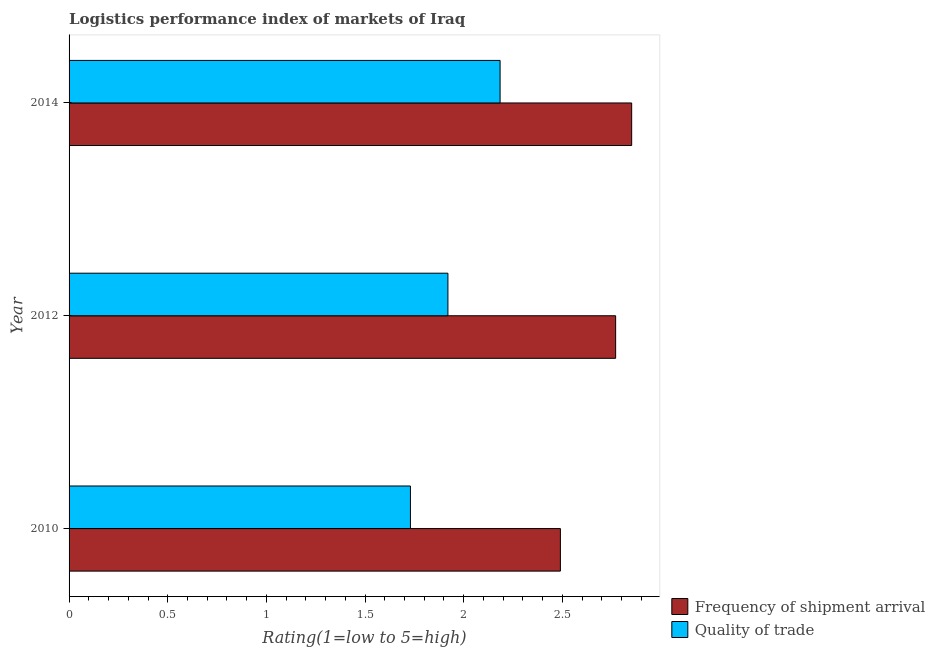How many groups of bars are there?
Offer a terse response. 3. How many bars are there on the 2nd tick from the bottom?
Offer a terse response. 2. In how many cases, is the number of bars for a given year not equal to the number of legend labels?
Provide a succinct answer. 0. What is the lpi of frequency of shipment arrival in 2012?
Give a very brief answer. 2.77. Across all years, what is the maximum lpi of frequency of shipment arrival?
Your answer should be very brief. 2.85. Across all years, what is the minimum lpi quality of trade?
Give a very brief answer. 1.73. In which year was the lpi quality of trade maximum?
Give a very brief answer. 2014. In which year was the lpi of frequency of shipment arrival minimum?
Make the answer very short. 2010. What is the total lpi quality of trade in the graph?
Provide a short and direct response. 5.83. What is the difference between the lpi quality of trade in 2012 and that in 2014?
Offer a very short reply. -0.26. What is the difference between the lpi quality of trade in 2010 and the lpi of frequency of shipment arrival in 2012?
Your response must be concise. -1.04. What is the average lpi quality of trade per year?
Give a very brief answer. 1.95. In the year 2012, what is the difference between the lpi quality of trade and lpi of frequency of shipment arrival?
Your answer should be very brief. -0.85. What is the ratio of the lpi quality of trade in 2010 to that in 2012?
Provide a short and direct response. 0.9. Is the lpi quality of trade in 2012 less than that in 2014?
Give a very brief answer. Yes. What is the difference between the highest and the second highest lpi quality of trade?
Your answer should be compact. 0.26. What is the difference between the highest and the lowest lpi of frequency of shipment arrival?
Offer a terse response. 0.36. In how many years, is the lpi of frequency of shipment arrival greater than the average lpi of frequency of shipment arrival taken over all years?
Keep it short and to the point. 2. Is the sum of the lpi of frequency of shipment arrival in 2012 and 2014 greater than the maximum lpi quality of trade across all years?
Offer a terse response. Yes. What does the 1st bar from the top in 2010 represents?
Provide a short and direct response. Quality of trade. What does the 2nd bar from the bottom in 2010 represents?
Your answer should be very brief. Quality of trade. Are the values on the major ticks of X-axis written in scientific E-notation?
Give a very brief answer. No. Does the graph contain any zero values?
Make the answer very short. No. Does the graph contain grids?
Keep it short and to the point. No. Where does the legend appear in the graph?
Provide a short and direct response. Bottom right. What is the title of the graph?
Keep it short and to the point. Logistics performance index of markets of Iraq. What is the label or title of the X-axis?
Your response must be concise. Rating(1=low to 5=high). What is the label or title of the Y-axis?
Provide a short and direct response. Year. What is the Rating(1=low to 5=high) of Frequency of shipment arrival in 2010?
Keep it short and to the point. 2.49. What is the Rating(1=low to 5=high) in Quality of trade in 2010?
Provide a short and direct response. 1.73. What is the Rating(1=low to 5=high) in Frequency of shipment arrival in 2012?
Offer a terse response. 2.77. What is the Rating(1=low to 5=high) in Quality of trade in 2012?
Your response must be concise. 1.92. What is the Rating(1=low to 5=high) in Frequency of shipment arrival in 2014?
Your response must be concise. 2.85. What is the Rating(1=low to 5=high) in Quality of trade in 2014?
Offer a very short reply. 2.18. Across all years, what is the maximum Rating(1=low to 5=high) in Frequency of shipment arrival?
Provide a succinct answer. 2.85. Across all years, what is the maximum Rating(1=low to 5=high) in Quality of trade?
Your answer should be compact. 2.18. Across all years, what is the minimum Rating(1=low to 5=high) of Frequency of shipment arrival?
Make the answer very short. 2.49. Across all years, what is the minimum Rating(1=low to 5=high) in Quality of trade?
Offer a terse response. 1.73. What is the total Rating(1=low to 5=high) of Frequency of shipment arrival in the graph?
Offer a very short reply. 8.11. What is the total Rating(1=low to 5=high) of Quality of trade in the graph?
Make the answer very short. 5.83. What is the difference between the Rating(1=low to 5=high) in Frequency of shipment arrival in 2010 and that in 2012?
Provide a short and direct response. -0.28. What is the difference between the Rating(1=low to 5=high) of Quality of trade in 2010 and that in 2012?
Give a very brief answer. -0.19. What is the difference between the Rating(1=low to 5=high) of Frequency of shipment arrival in 2010 and that in 2014?
Provide a succinct answer. -0.36. What is the difference between the Rating(1=low to 5=high) in Quality of trade in 2010 and that in 2014?
Offer a very short reply. -0.45. What is the difference between the Rating(1=low to 5=high) in Frequency of shipment arrival in 2012 and that in 2014?
Provide a short and direct response. -0.08. What is the difference between the Rating(1=low to 5=high) of Quality of trade in 2012 and that in 2014?
Ensure brevity in your answer.  -0.26. What is the difference between the Rating(1=low to 5=high) of Frequency of shipment arrival in 2010 and the Rating(1=low to 5=high) of Quality of trade in 2012?
Give a very brief answer. 0.57. What is the difference between the Rating(1=low to 5=high) in Frequency of shipment arrival in 2010 and the Rating(1=low to 5=high) in Quality of trade in 2014?
Offer a terse response. 0.31. What is the difference between the Rating(1=low to 5=high) in Frequency of shipment arrival in 2012 and the Rating(1=low to 5=high) in Quality of trade in 2014?
Make the answer very short. 0.59. What is the average Rating(1=low to 5=high) of Frequency of shipment arrival per year?
Offer a very short reply. 2.7. What is the average Rating(1=low to 5=high) in Quality of trade per year?
Your response must be concise. 1.94. In the year 2010, what is the difference between the Rating(1=low to 5=high) in Frequency of shipment arrival and Rating(1=low to 5=high) in Quality of trade?
Offer a very short reply. 0.76. In the year 2014, what is the difference between the Rating(1=low to 5=high) in Frequency of shipment arrival and Rating(1=low to 5=high) in Quality of trade?
Offer a terse response. 0.67. What is the ratio of the Rating(1=low to 5=high) of Frequency of shipment arrival in 2010 to that in 2012?
Provide a succinct answer. 0.9. What is the ratio of the Rating(1=low to 5=high) of Quality of trade in 2010 to that in 2012?
Your answer should be compact. 0.9. What is the ratio of the Rating(1=low to 5=high) in Frequency of shipment arrival in 2010 to that in 2014?
Your response must be concise. 0.87. What is the ratio of the Rating(1=low to 5=high) in Quality of trade in 2010 to that in 2014?
Provide a short and direct response. 0.79. What is the ratio of the Rating(1=low to 5=high) in Frequency of shipment arrival in 2012 to that in 2014?
Offer a terse response. 0.97. What is the ratio of the Rating(1=low to 5=high) of Quality of trade in 2012 to that in 2014?
Give a very brief answer. 0.88. What is the difference between the highest and the second highest Rating(1=low to 5=high) in Frequency of shipment arrival?
Your answer should be compact. 0.08. What is the difference between the highest and the second highest Rating(1=low to 5=high) in Quality of trade?
Offer a terse response. 0.26. What is the difference between the highest and the lowest Rating(1=low to 5=high) in Frequency of shipment arrival?
Provide a succinct answer. 0.36. What is the difference between the highest and the lowest Rating(1=low to 5=high) of Quality of trade?
Keep it short and to the point. 0.45. 